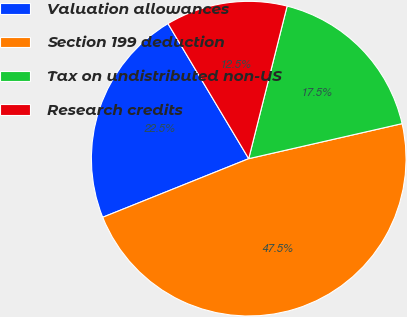Convert chart to OTSL. <chart><loc_0><loc_0><loc_500><loc_500><pie_chart><fcel>Valuation allowances<fcel>Section 199 deduction<fcel>Tax on undistributed non-US<fcel>Research credits<nl><fcel>22.5%<fcel>47.5%<fcel>17.5%<fcel>12.5%<nl></chart> 